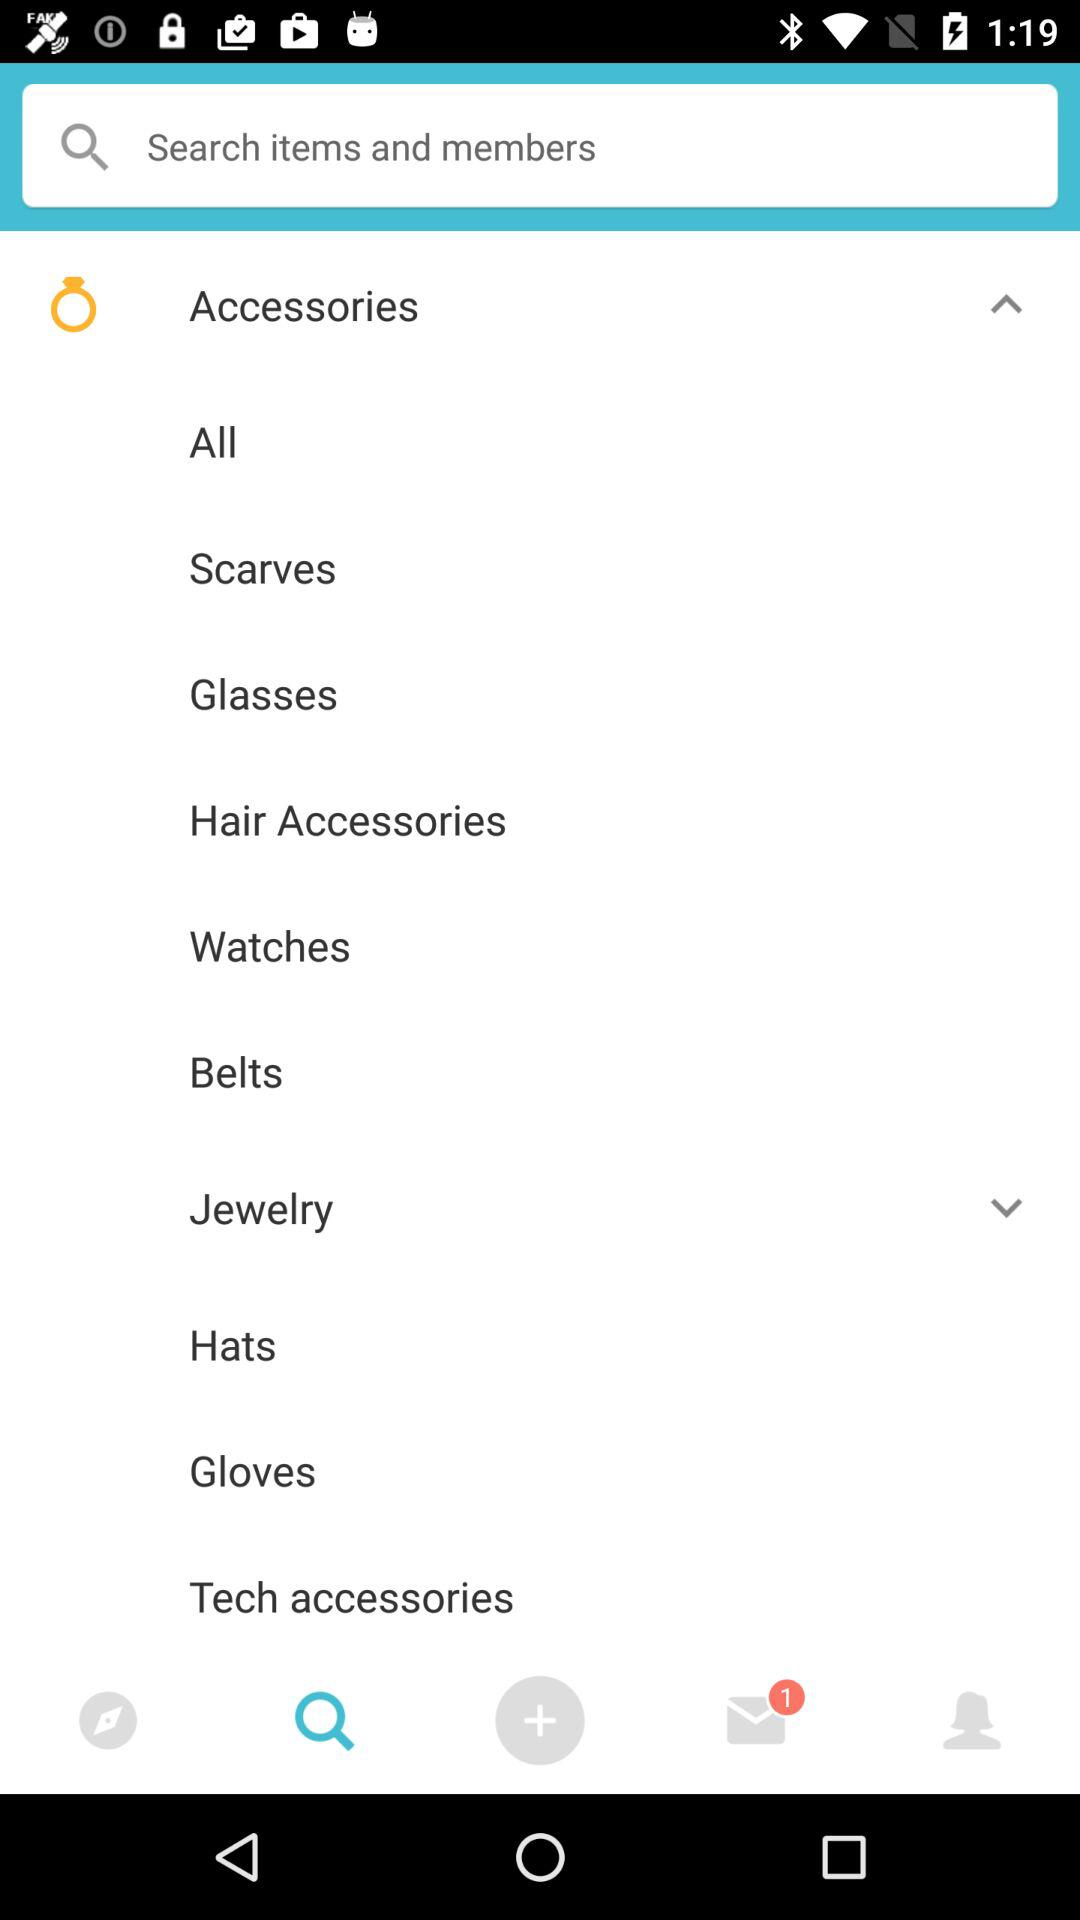What is the number of unread messages? The number of unread messages is 1. 